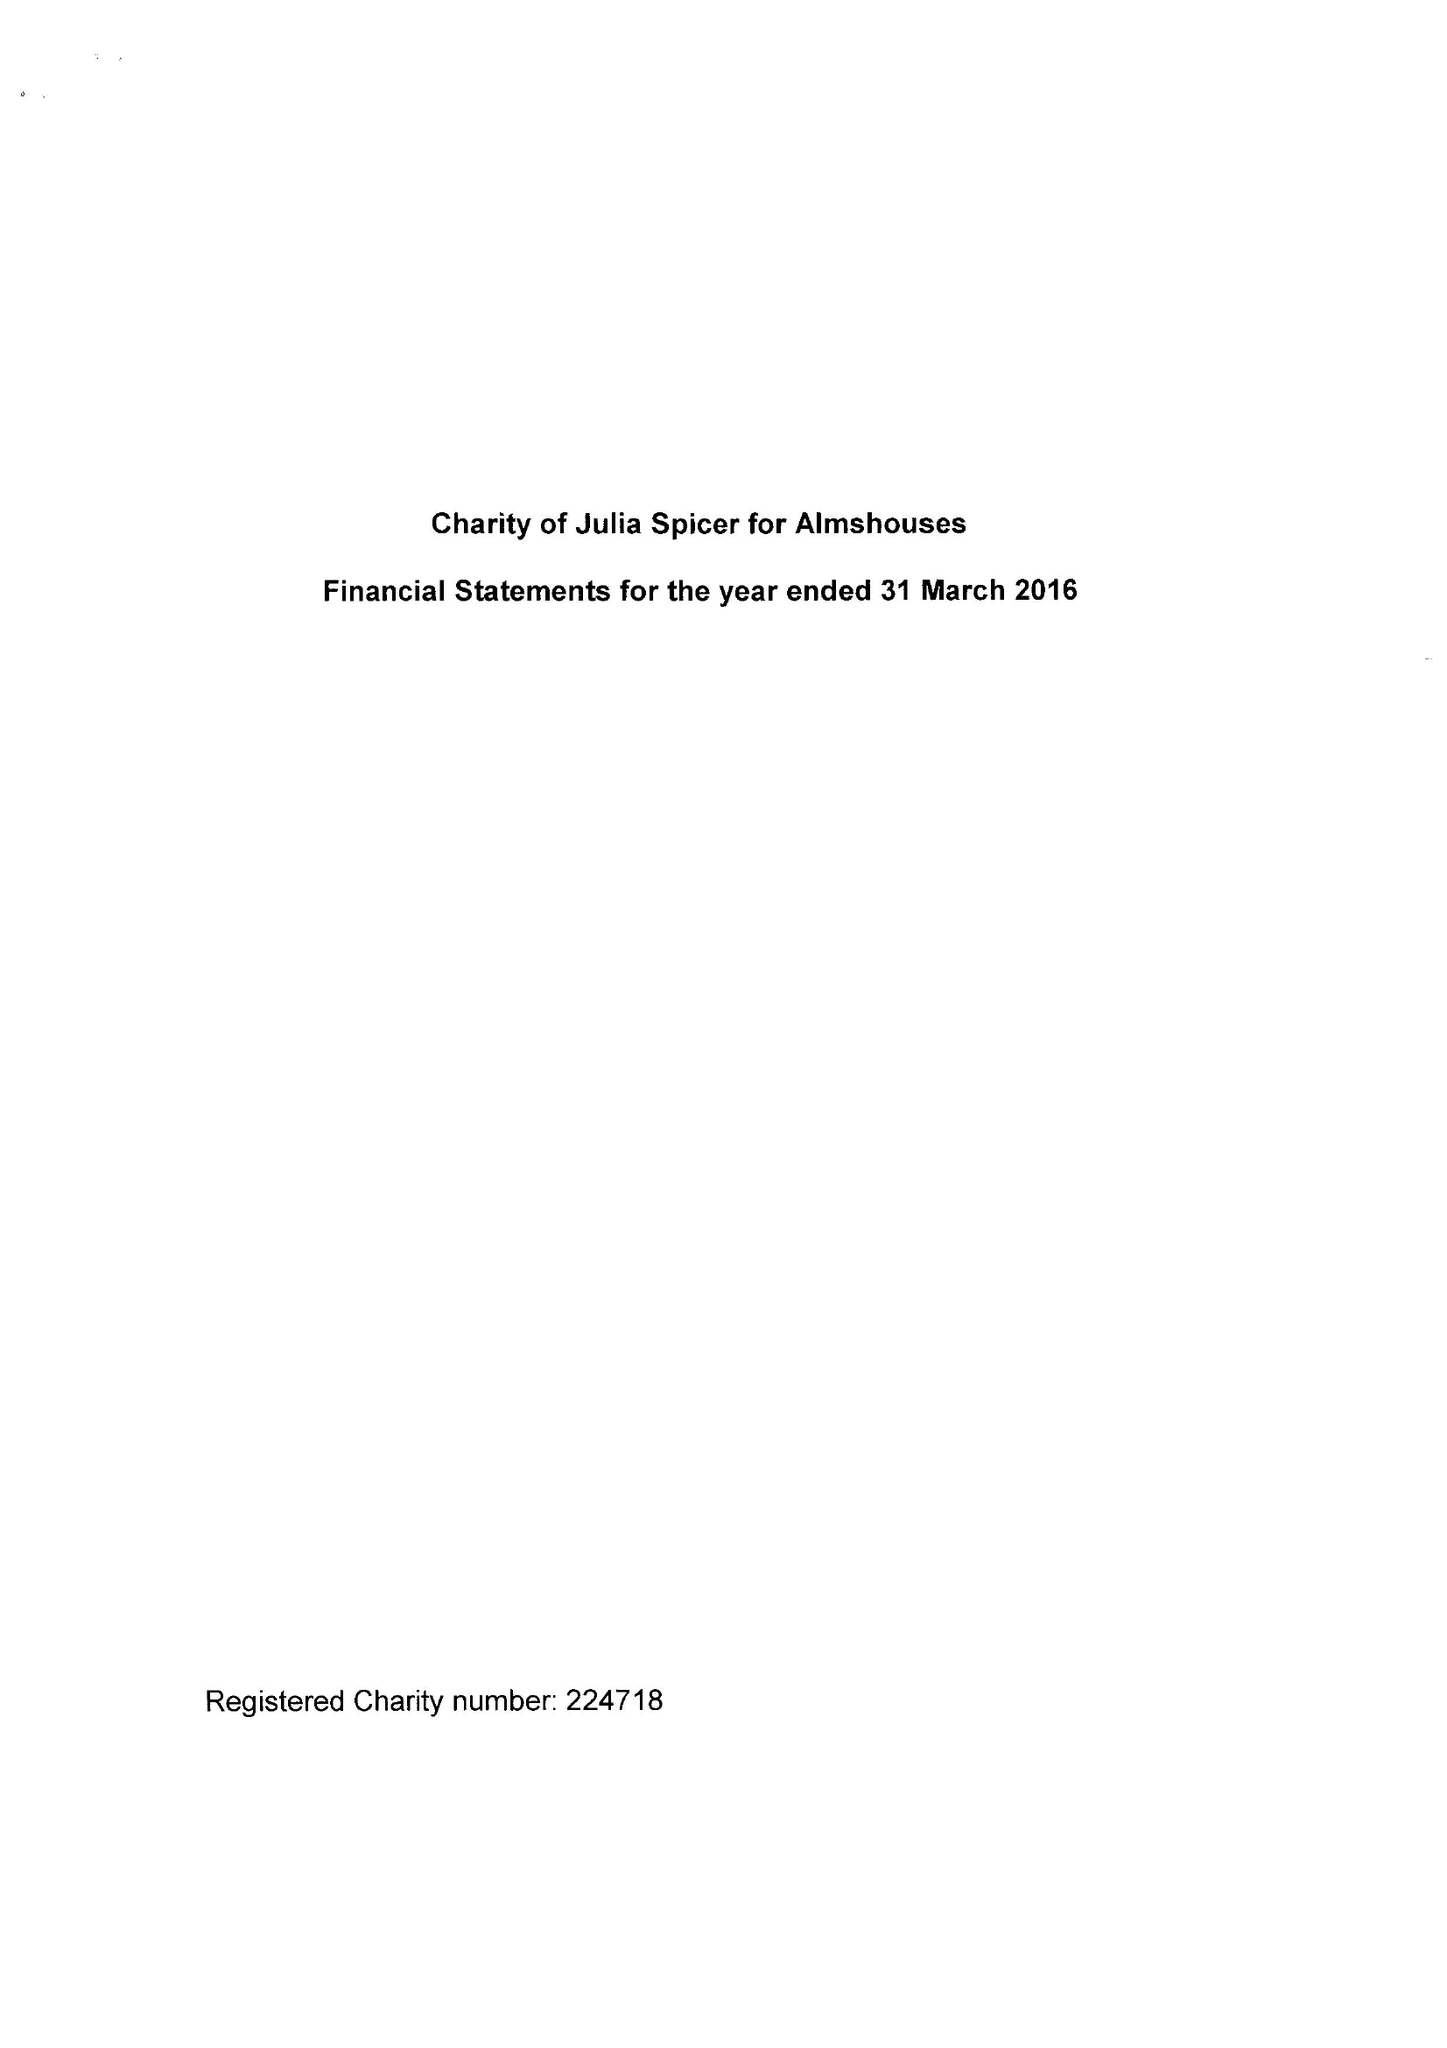What is the value for the income_annually_in_british_pounds?
Answer the question using a single word or phrase. 69687.00 